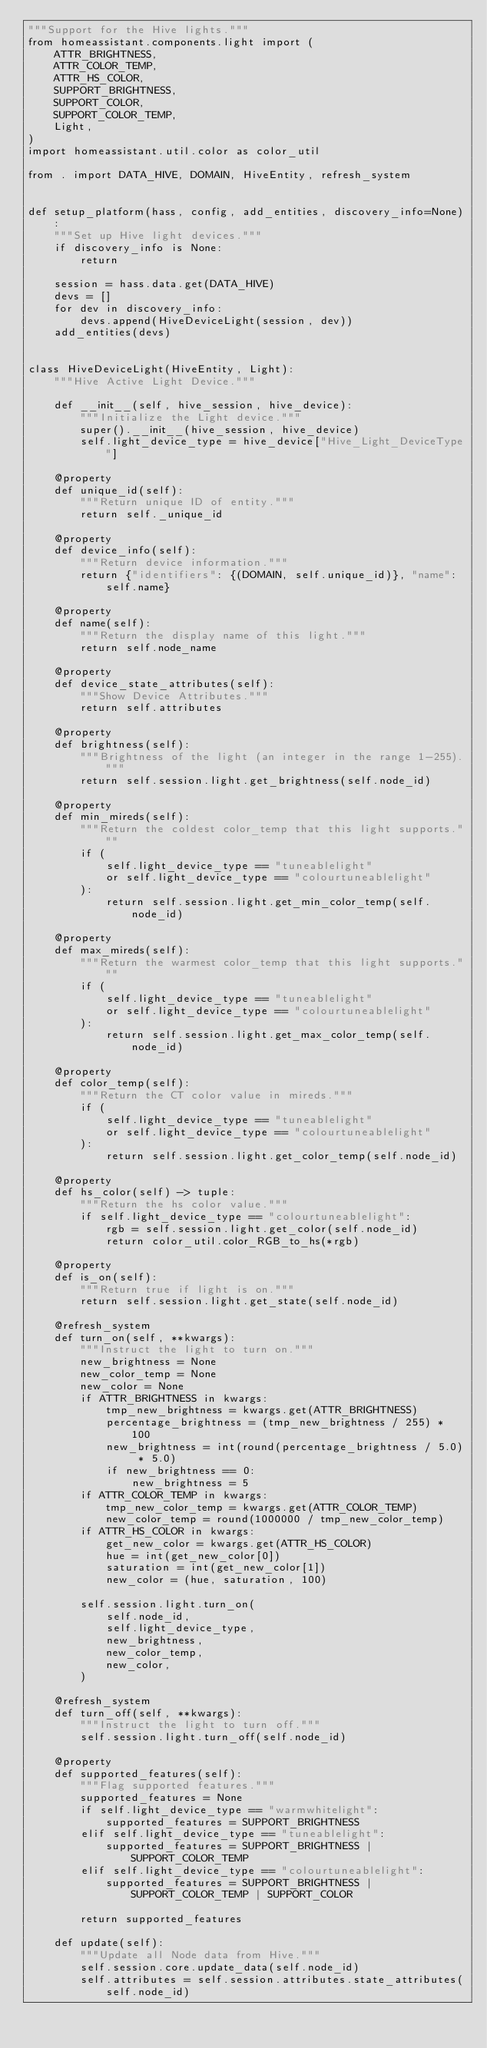<code> <loc_0><loc_0><loc_500><loc_500><_Python_>"""Support for the Hive lights."""
from homeassistant.components.light import (
    ATTR_BRIGHTNESS,
    ATTR_COLOR_TEMP,
    ATTR_HS_COLOR,
    SUPPORT_BRIGHTNESS,
    SUPPORT_COLOR,
    SUPPORT_COLOR_TEMP,
    Light,
)
import homeassistant.util.color as color_util

from . import DATA_HIVE, DOMAIN, HiveEntity, refresh_system


def setup_platform(hass, config, add_entities, discovery_info=None):
    """Set up Hive light devices."""
    if discovery_info is None:
        return

    session = hass.data.get(DATA_HIVE)
    devs = []
    for dev in discovery_info:
        devs.append(HiveDeviceLight(session, dev))
    add_entities(devs)


class HiveDeviceLight(HiveEntity, Light):
    """Hive Active Light Device."""

    def __init__(self, hive_session, hive_device):
        """Initialize the Light device."""
        super().__init__(hive_session, hive_device)
        self.light_device_type = hive_device["Hive_Light_DeviceType"]

    @property
    def unique_id(self):
        """Return unique ID of entity."""
        return self._unique_id

    @property
    def device_info(self):
        """Return device information."""
        return {"identifiers": {(DOMAIN, self.unique_id)}, "name": self.name}

    @property
    def name(self):
        """Return the display name of this light."""
        return self.node_name

    @property
    def device_state_attributes(self):
        """Show Device Attributes."""
        return self.attributes

    @property
    def brightness(self):
        """Brightness of the light (an integer in the range 1-255)."""
        return self.session.light.get_brightness(self.node_id)

    @property
    def min_mireds(self):
        """Return the coldest color_temp that this light supports."""
        if (
            self.light_device_type == "tuneablelight"
            or self.light_device_type == "colourtuneablelight"
        ):
            return self.session.light.get_min_color_temp(self.node_id)

    @property
    def max_mireds(self):
        """Return the warmest color_temp that this light supports."""
        if (
            self.light_device_type == "tuneablelight"
            or self.light_device_type == "colourtuneablelight"
        ):
            return self.session.light.get_max_color_temp(self.node_id)

    @property
    def color_temp(self):
        """Return the CT color value in mireds."""
        if (
            self.light_device_type == "tuneablelight"
            or self.light_device_type == "colourtuneablelight"
        ):
            return self.session.light.get_color_temp(self.node_id)

    @property
    def hs_color(self) -> tuple:
        """Return the hs color value."""
        if self.light_device_type == "colourtuneablelight":
            rgb = self.session.light.get_color(self.node_id)
            return color_util.color_RGB_to_hs(*rgb)

    @property
    def is_on(self):
        """Return true if light is on."""
        return self.session.light.get_state(self.node_id)

    @refresh_system
    def turn_on(self, **kwargs):
        """Instruct the light to turn on."""
        new_brightness = None
        new_color_temp = None
        new_color = None
        if ATTR_BRIGHTNESS in kwargs:
            tmp_new_brightness = kwargs.get(ATTR_BRIGHTNESS)
            percentage_brightness = (tmp_new_brightness / 255) * 100
            new_brightness = int(round(percentage_brightness / 5.0) * 5.0)
            if new_brightness == 0:
                new_brightness = 5
        if ATTR_COLOR_TEMP in kwargs:
            tmp_new_color_temp = kwargs.get(ATTR_COLOR_TEMP)
            new_color_temp = round(1000000 / tmp_new_color_temp)
        if ATTR_HS_COLOR in kwargs:
            get_new_color = kwargs.get(ATTR_HS_COLOR)
            hue = int(get_new_color[0])
            saturation = int(get_new_color[1])
            new_color = (hue, saturation, 100)

        self.session.light.turn_on(
            self.node_id,
            self.light_device_type,
            new_brightness,
            new_color_temp,
            new_color,
        )

    @refresh_system
    def turn_off(self, **kwargs):
        """Instruct the light to turn off."""
        self.session.light.turn_off(self.node_id)

    @property
    def supported_features(self):
        """Flag supported features."""
        supported_features = None
        if self.light_device_type == "warmwhitelight":
            supported_features = SUPPORT_BRIGHTNESS
        elif self.light_device_type == "tuneablelight":
            supported_features = SUPPORT_BRIGHTNESS | SUPPORT_COLOR_TEMP
        elif self.light_device_type == "colourtuneablelight":
            supported_features = SUPPORT_BRIGHTNESS | SUPPORT_COLOR_TEMP | SUPPORT_COLOR

        return supported_features

    def update(self):
        """Update all Node data from Hive."""
        self.session.core.update_data(self.node_id)
        self.attributes = self.session.attributes.state_attributes(self.node_id)
</code> 